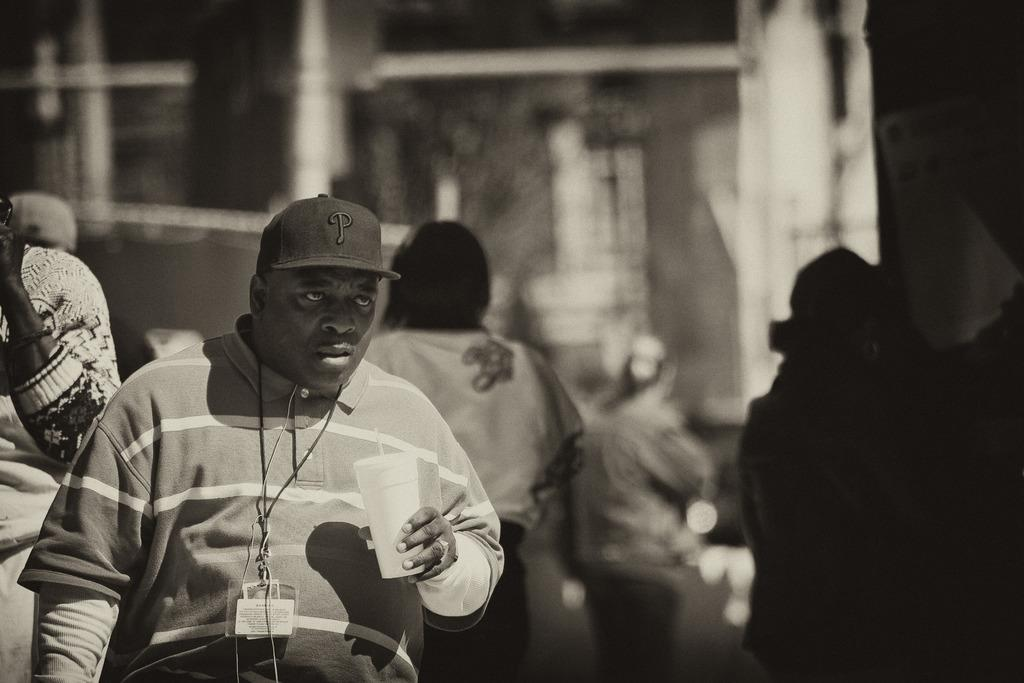What can be seen on the right side of the image? There is a person on the right side of the image. What is the person wearing? The person is wearing a cap. What is the person holding? The person is holding a glass. What can be observed about the people in the background of the image? The people in the background are blurred. What type of bread is the person eating in the image? There is no bread present in the image; the person is holding a glass. What sound does the horn make in the image? There is no horn present in the image. 